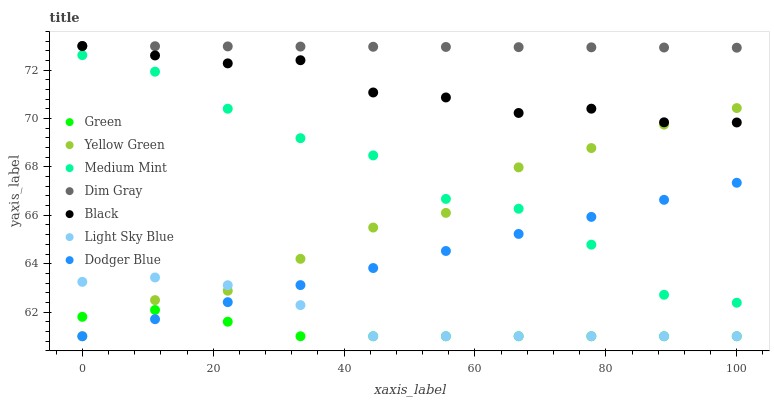Does Green have the minimum area under the curve?
Answer yes or no. Yes. Does Dim Gray have the maximum area under the curve?
Answer yes or no. Yes. Does Yellow Green have the minimum area under the curve?
Answer yes or no. No. Does Yellow Green have the maximum area under the curve?
Answer yes or no. No. Is Dodger Blue the smoothest?
Answer yes or no. Yes. Is Medium Mint the roughest?
Answer yes or no. Yes. Is Dim Gray the smoothest?
Answer yes or no. No. Is Dim Gray the roughest?
Answer yes or no. No. Does Yellow Green have the lowest value?
Answer yes or no. Yes. Does Dim Gray have the lowest value?
Answer yes or no. No. Does Black have the highest value?
Answer yes or no. Yes. Does Yellow Green have the highest value?
Answer yes or no. No. Is Light Sky Blue less than Black?
Answer yes or no. Yes. Is Black greater than Medium Mint?
Answer yes or no. Yes. Does Yellow Green intersect Green?
Answer yes or no. Yes. Is Yellow Green less than Green?
Answer yes or no. No. Is Yellow Green greater than Green?
Answer yes or no. No. Does Light Sky Blue intersect Black?
Answer yes or no. No. 